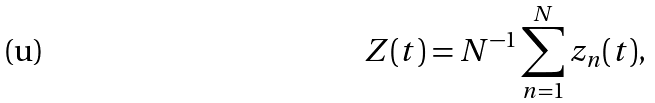<formula> <loc_0><loc_0><loc_500><loc_500>Z ( t ) = N ^ { - 1 } \sum ^ { N } _ { n = 1 } z _ { n } ( t ) ,</formula> 